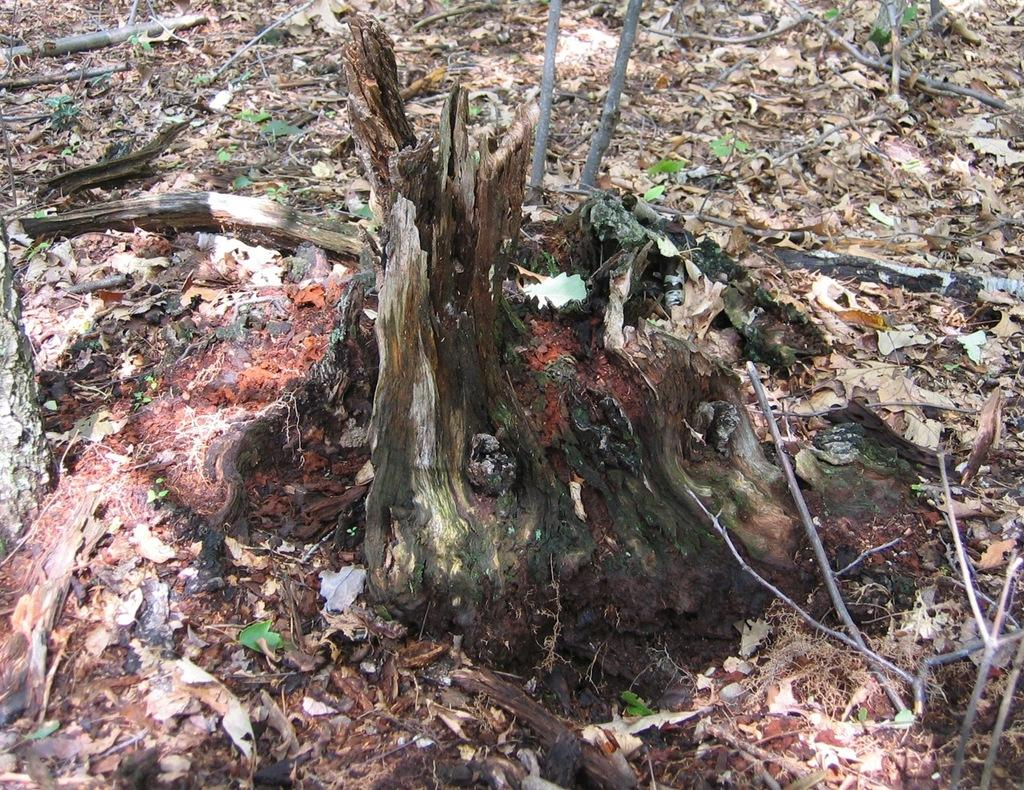What type of natural elements can be seen on the ground in the image? There are leaves on the ground in the image. What other natural elements can be seen in the image? There are sticks visible in the image. Are there any small plants present in the image? Yes, there are small plants in the image. How many cherries are hanging from the small plants in the image? There are no cherries present in the image; it only features leaves, sticks, and small plants. 